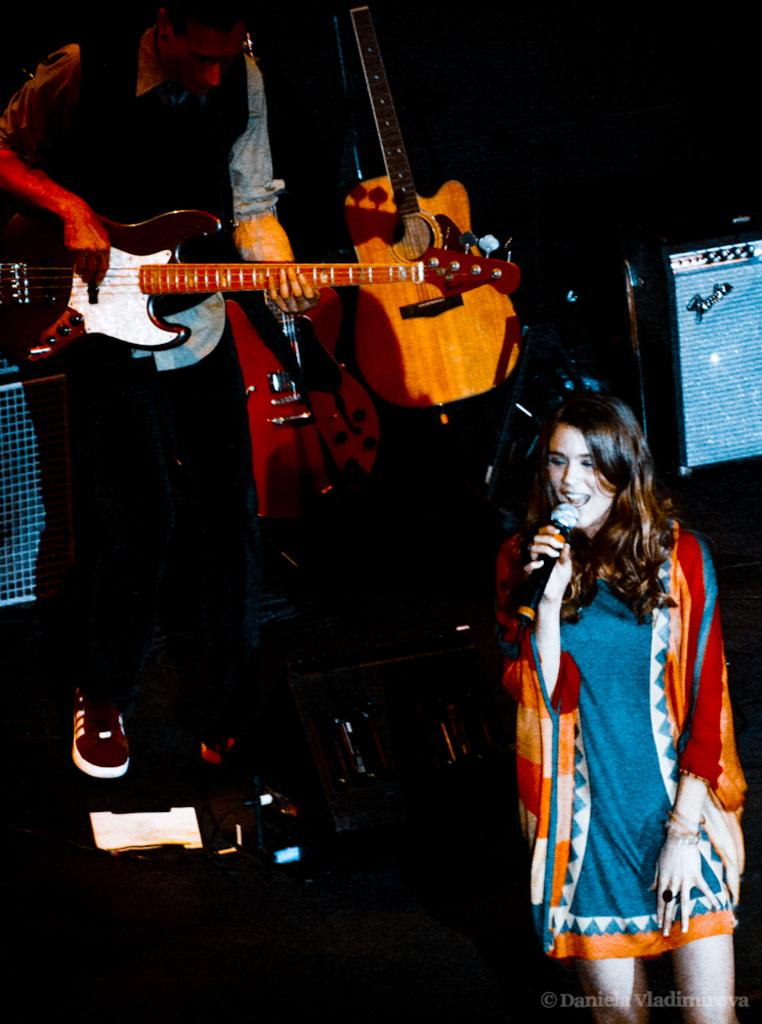What is the woman in the image doing? The woman is singing in the image. What object is the woman using while singing? There is a microphone in the image. What is the man in the image doing? The man is playing a guitar in the image. What type of ground can be seen in the image? There is no ground visible in the image; it appears to be an indoor setting. What is the woman doing with the ring in the image? There is no ring present in the image. 